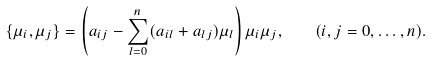Convert formula to latex. <formula><loc_0><loc_0><loc_500><loc_500>\{ \mu _ { i } , \mu _ { j } \} = \left ( a _ { i j } - \sum _ { l = 0 } ^ { n } ( a _ { i l } + a _ { l j } ) \mu _ { l } \right ) \mu _ { i } \mu _ { j } , \quad ( i , j = 0 , \dots , n ) .</formula> 